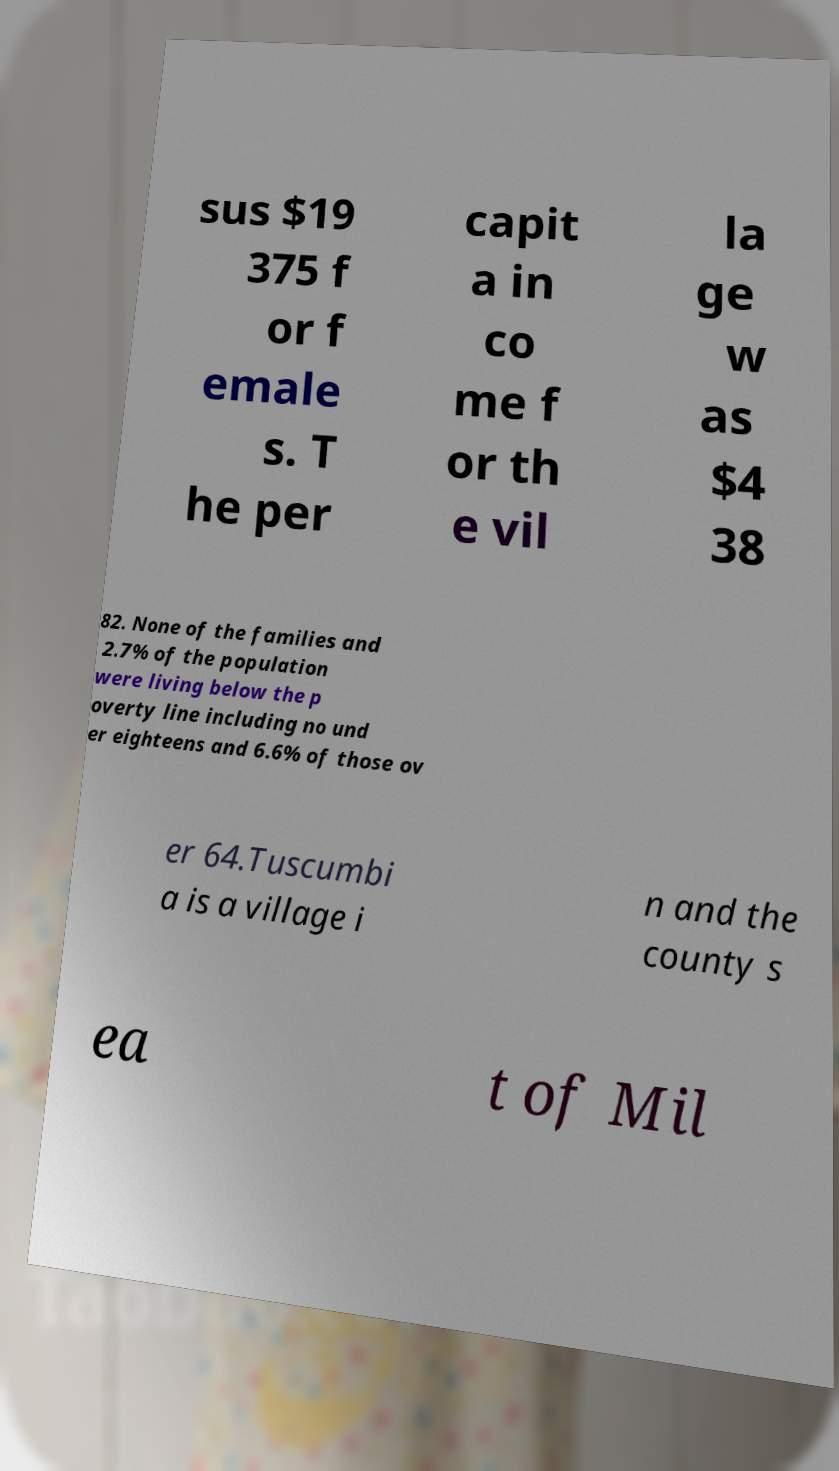There's text embedded in this image that I need extracted. Can you transcribe it verbatim? sus $19 375 f or f emale s. T he per capit a in co me f or th e vil la ge w as $4 38 82. None of the families and 2.7% of the population were living below the p overty line including no und er eighteens and 6.6% of those ov er 64.Tuscumbi a is a village i n and the county s ea t of Mil 